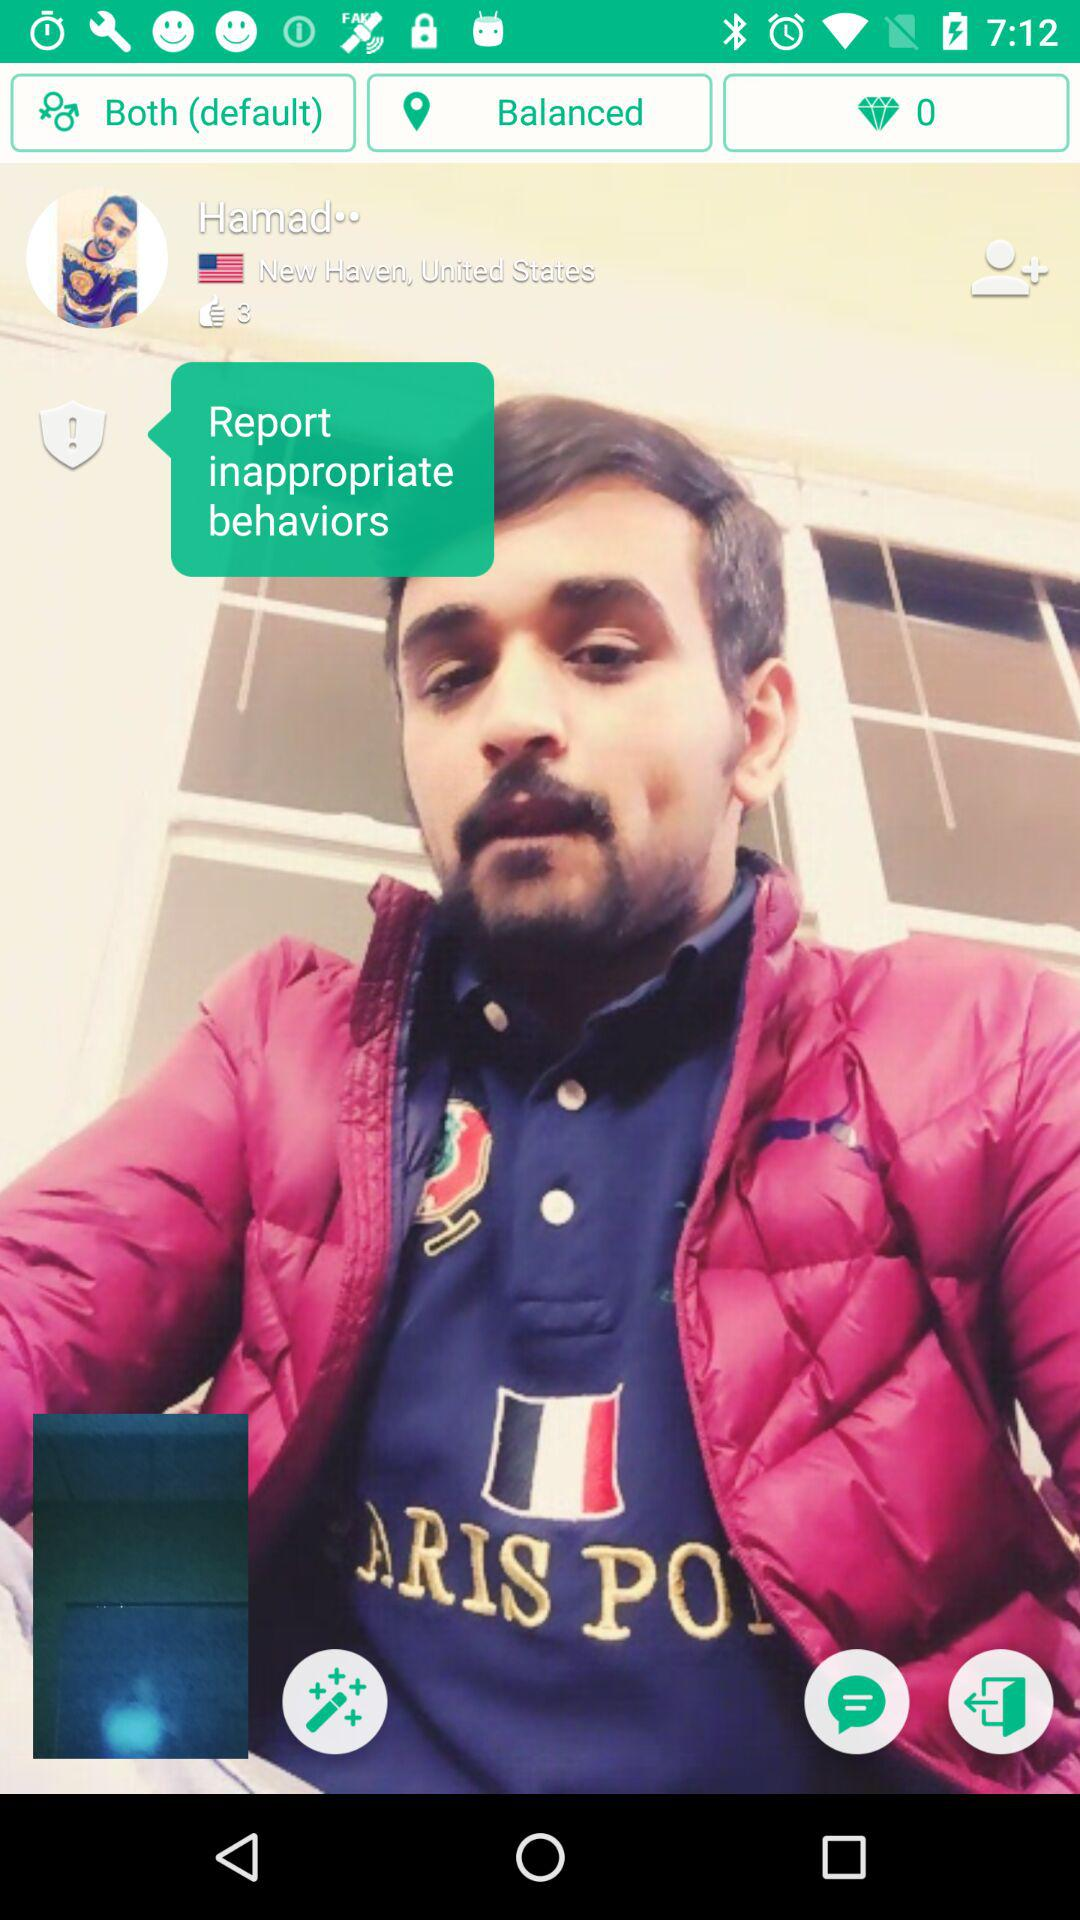Who has posted the photo? The photo was posted by Hamad. 